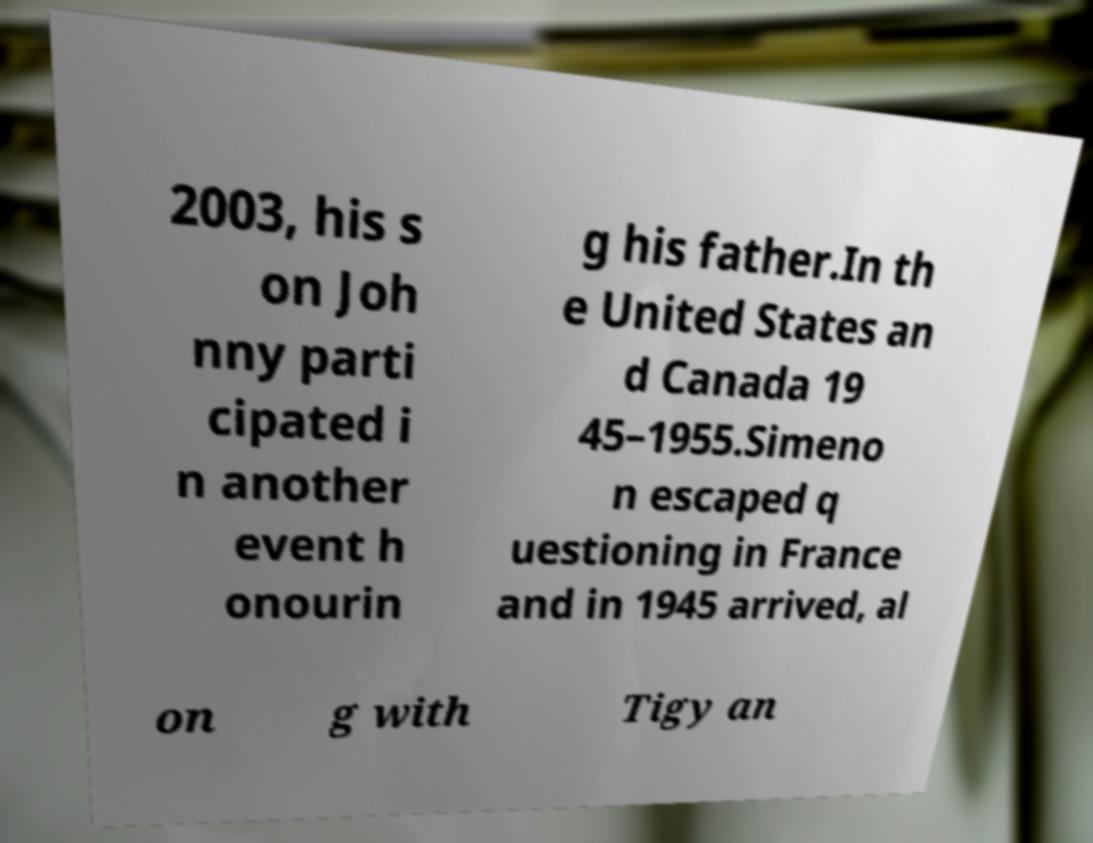I need the written content from this picture converted into text. Can you do that? 2003, his s on Joh nny parti cipated i n another event h onourin g his father.In th e United States an d Canada 19 45–1955.Simeno n escaped q uestioning in France and in 1945 arrived, al on g with Tigy an 